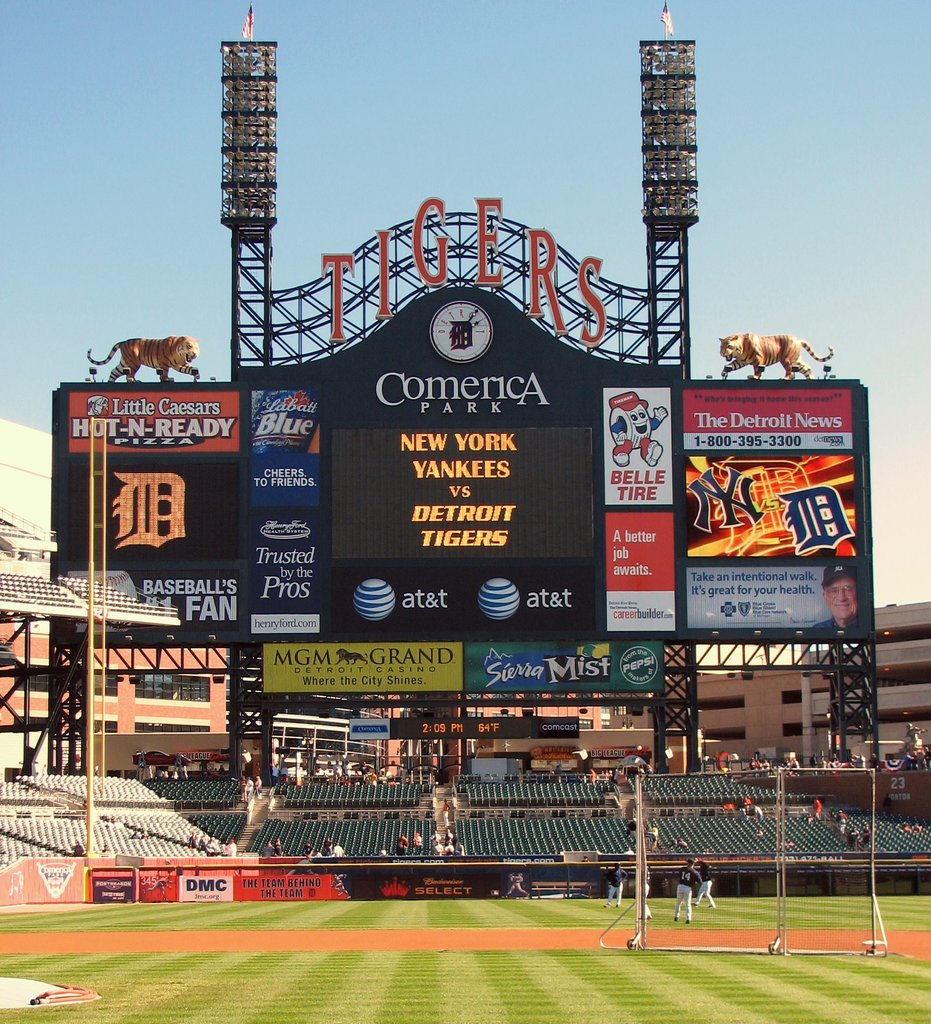Can you describe the atmosphere or mood conveyed by this image? The image conveys an atmosphere of anticipation and excitement typical of major sporting events, with a clear, sunny day setting the perfect scene for a baseball game. The vibrancy of the scoreboard and the presence of the stadium's iconic decorations, like the tiger statues, enhance the festive mood. 